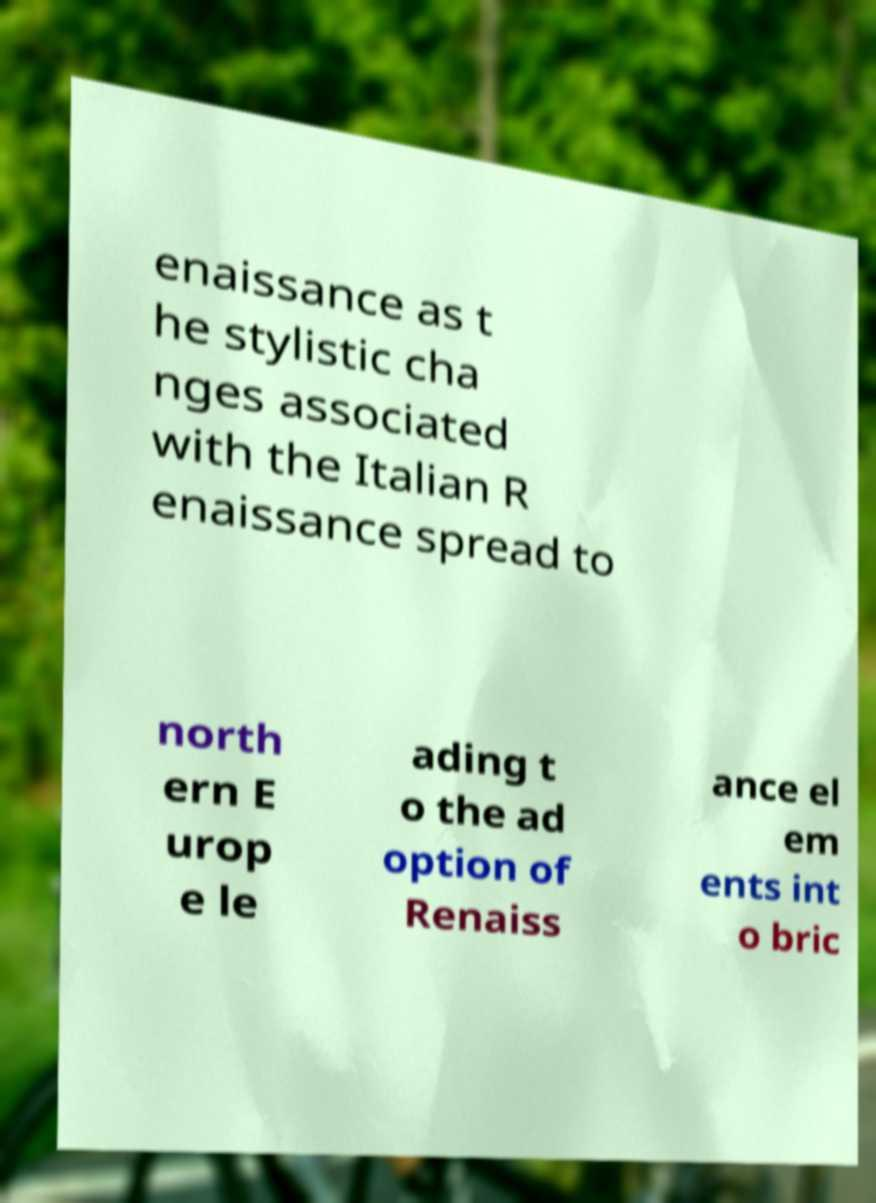Can you read and provide the text displayed in the image?This photo seems to have some interesting text. Can you extract and type it out for me? enaissance as t he stylistic cha nges associated with the Italian R enaissance spread to north ern E urop e le ading t o the ad option of Renaiss ance el em ents int o bric 